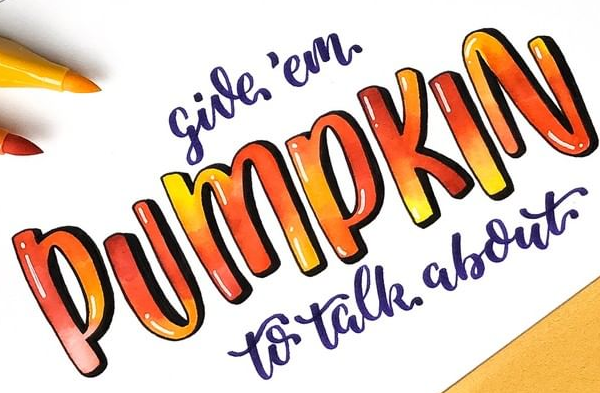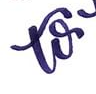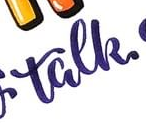What text appears in these images from left to right, separated by a semicolon? PUMPKIN; to; talk 